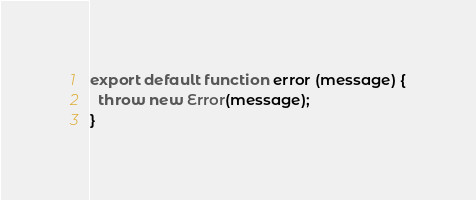Convert code to text. <code><loc_0><loc_0><loc_500><loc_500><_JavaScript_>export default function error (message) {
  throw new Error(message);
}
</code> 